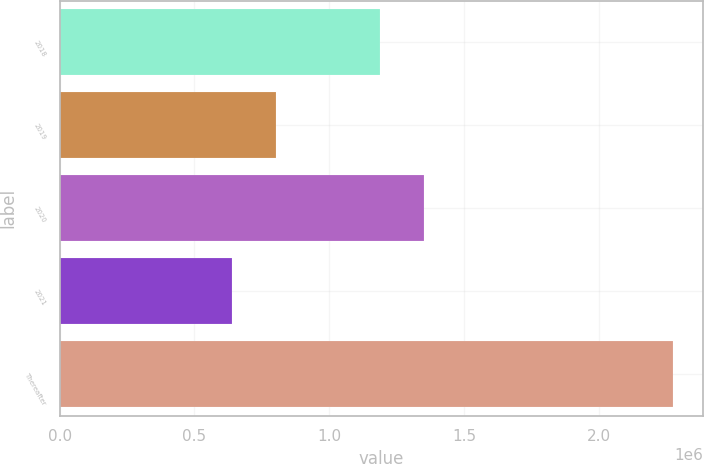<chart> <loc_0><loc_0><loc_500><loc_500><bar_chart><fcel>2018<fcel>2019<fcel>2020<fcel>2021<fcel>Thereafter<nl><fcel>1.18851e+06<fcel>804113<fcel>1.35189e+06<fcel>640734<fcel>2.27453e+06<nl></chart> 